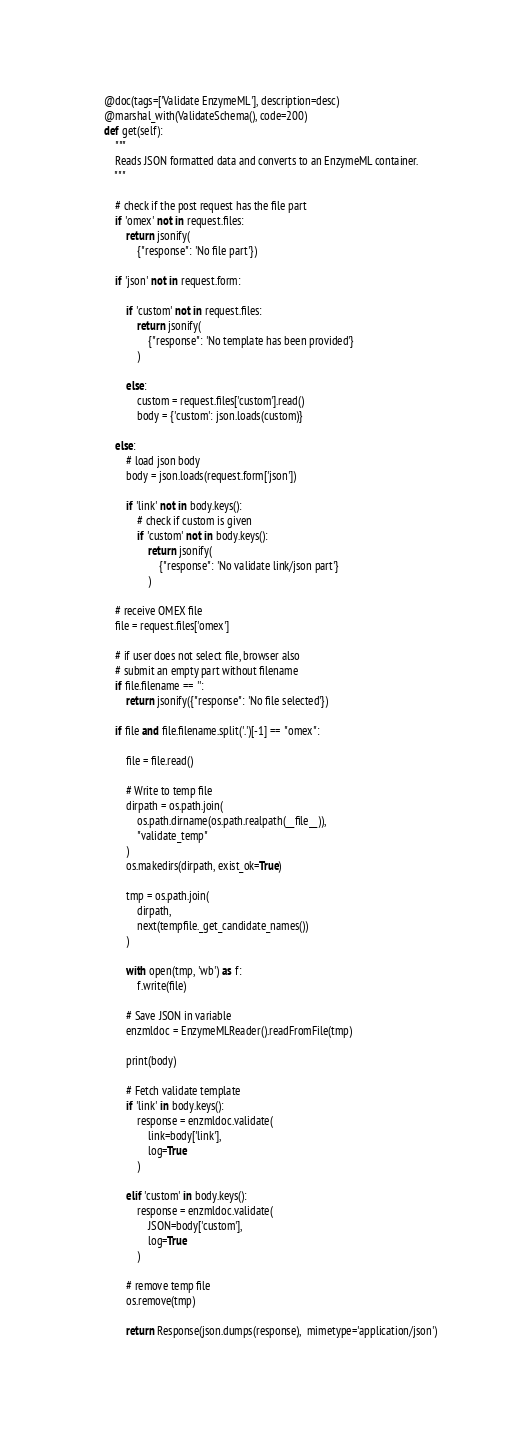<code> <loc_0><loc_0><loc_500><loc_500><_Python_>    @doc(tags=['Validate EnzymeML'], description=desc)
    @marshal_with(ValidateSchema(), code=200)
    def get(self):
        """
        Reads JSON formatted data and converts to an EnzymeML container.
        """

        # check if the post request has the file part
        if 'omex' not in request.files:
            return jsonify(
                {"response": 'No file part'})

        if 'json' not in request.form:

            if 'custom' not in request.files:
                return jsonify(
                    {"response": 'No template has been provided'}
                )

            else:
                custom = request.files['custom'].read()
                body = {'custom': json.loads(custom)}

        else:
            # load json body
            body = json.loads(request.form['json'])

            if 'link' not in body.keys():
                # check if custom is given
                if 'custom' not in body.keys():
                    return jsonify(
                        {"response": 'No validate link/json part'}
                    )

        # receive OMEX file
        file = request.files['omex']

        # if user does not select file, browser also
        # submit an empty part without filename
        if file.filename == '':
            return jsonify({"response": 'No file selected'})

        if file and file.filename.split('.')[-1] == "omex":

            file = file.read()

            # Write to temp file
            dirpath = os.path.join(
                os.path.dirname(os.path.realpath(__file__)),
                "validate_temp"
            )
            os.makedirs(dirpath, exist_ok=True)

            tmp = os.path.join(
                dirpath,
                next(tempfile._get_candidate_names())
            )

            with open(tmp, 'wb') as f:
                f.write(file)

            # Save JSON in variable
            enzmldoc = EnzymeMLReader().readFromFile(tmp)

            print(body)

            # Fetch validate template
            if 'link' in body.keys():
                response = enzmldoc.validate(
                    link=body['link'],
                    log=True
                )

            elif 'custom' in body.keys():
                response = enzmldoc.validate(
                    JSON=body['custom'],
                    log=True
                )

            # remove temp file
            os.remove(tmp)

            return Response(json.dumps(response),  mimetype='application/json')
</code> 